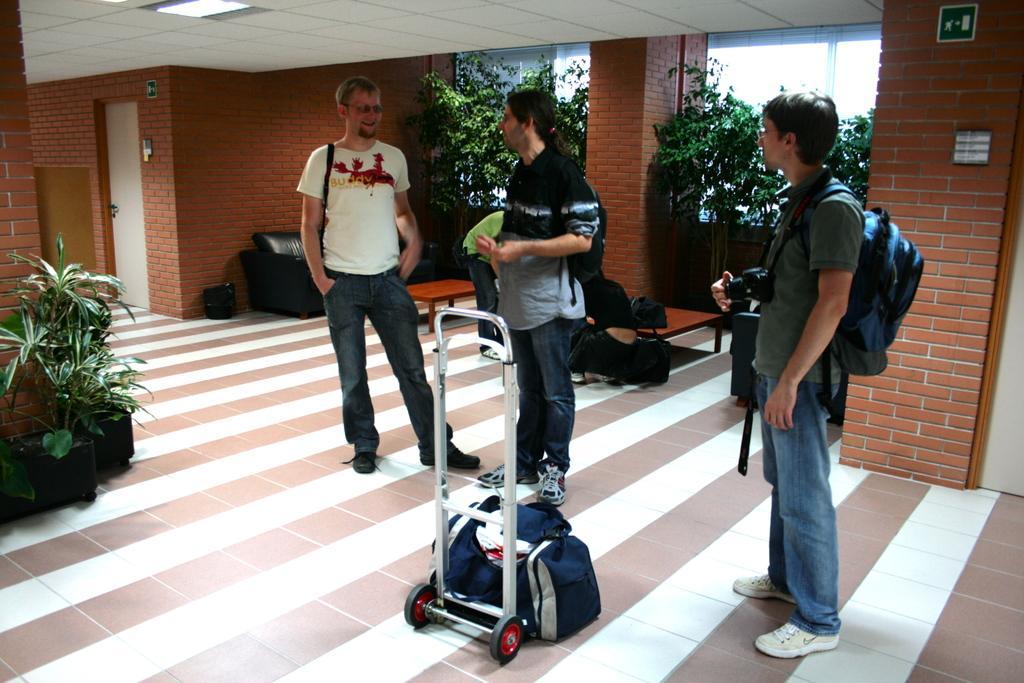How would you summarize this image in a sentence or two? In the picture I can see a person wearing white color T-shirt, a person wearing a shirt and a person wearing T-shirt is carrying a backpack and camera, are standing on the floor. Here I can see a bag is kept near the trolley, here I can see flower pots, tables, sofas, I can see plants brick wall, glass windows and ceiling light in the background 